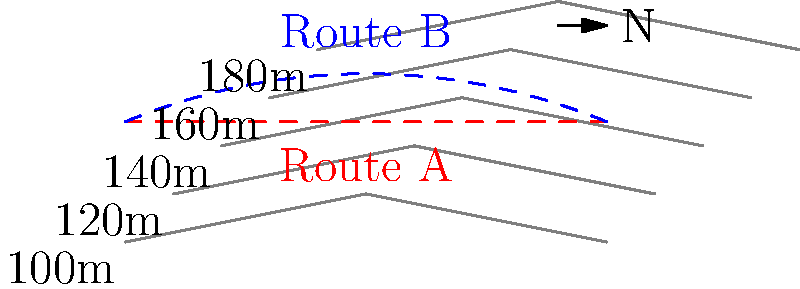As a taekwondo grandmaster who values efficiency and strategic planning, you are asked to consult on a civil engineering project. Given the topographic map above showing two potential routes (A and B) for a new highway, which route would you recommend based on the principles of balance and energy conservation that you apply in your martial arts training? To answer this question, we need to analyze the topographic map and apply principles of balance and energy conservation, which are fundamental in both taekwondo and efficient road design. Let's break down the analysis step-by-step:

1. Contour line interpretation:
   - The contour lines represent elevation changes.
   - Closer lines indicate steeper terrain, while wider spacing indicates gentler slopes.

2. Route A (red dashed line):
   - This route maintains a constant elevation, following a single contour line.
   - It represents a path of least resistance, similar to maintaining a balanced stance in taekwondo.

3. Route B (blue dashed line):
   - This route involves climbing to a higher elevation and then descending.
   - It represents a more challenging path, requiring more energy expenditure.

4. Energy conservation principle:
   - In taekwondo, conserving energy is crucial for endurance and effectiveness.
   - Similarly, in road design, minimizing elevation changes reduces fuel consumption and vehicle wear.

5. Balance principle:
   - Taekwondo emphasizes maintaining balance for optimal performance.
   - In road design, a balanced route with minimal elevation changes provides safer and more efficient travel.

6. Environmental impact:
   - A route that follows natural contours (like Route A) typically requires less earthwork and has a lower environmental impact.
   - This aligns with the respect for nature often emphasized in martial arts philosophy.

7. Long-term sustainability:
   - Route A would likely require less maintenance over time due to reduced stress on the road surface from elevation changes.
   - This reflects the taekwondo principle of long-term discipline and sustained practice.

Based on these considerations, Route A aligns more closely with the principles of balance, energy conservation, and harmony with the environment that are central to taekwondo philosophy and effective civil engineering.
Answer: Route A 